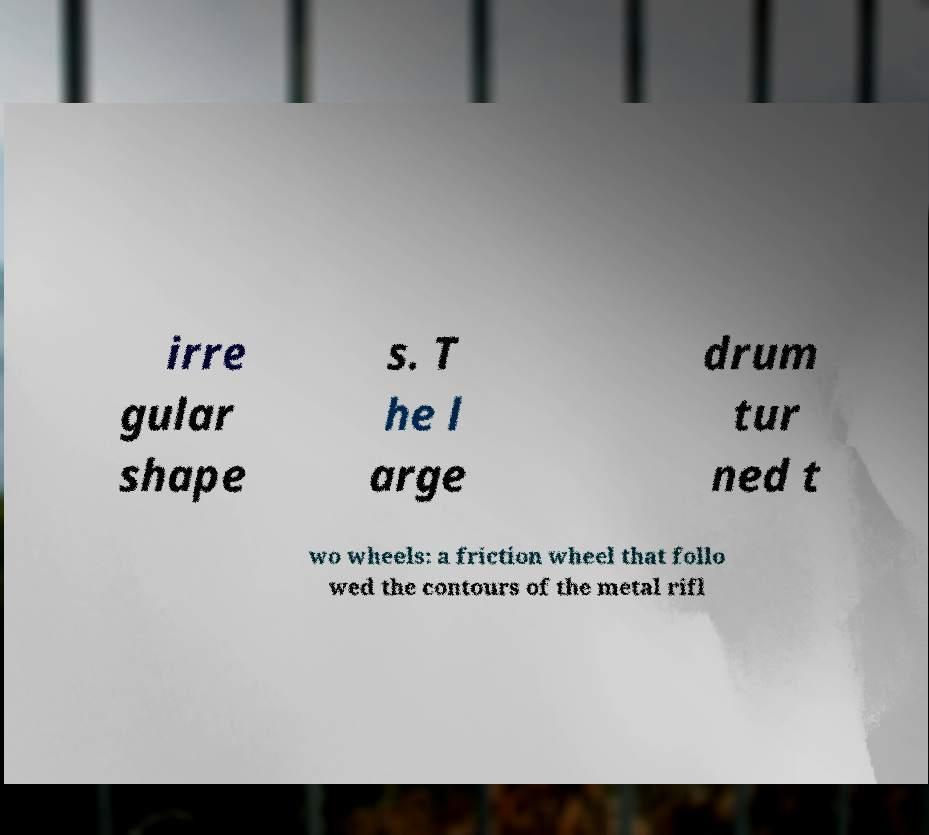Please identify and transcribe the text found in this image. irre gular shape s. T he l arge drum tur ned t wo wheels: a friction wheel that follo wed the contours of the metal rifl 